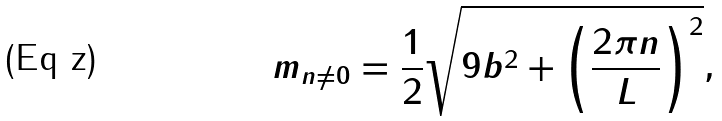Convert formula to latex. <formula><loc_0><loc_0><loc_500><loc_500>m _ { n \neq 0 } = \frac { 1 } { 2 } \sqrt { 9 b ^ { 2 } + \left ( \frac { 2 \pi n } { L } \right ) ^ { 2 } } ,</formula> 